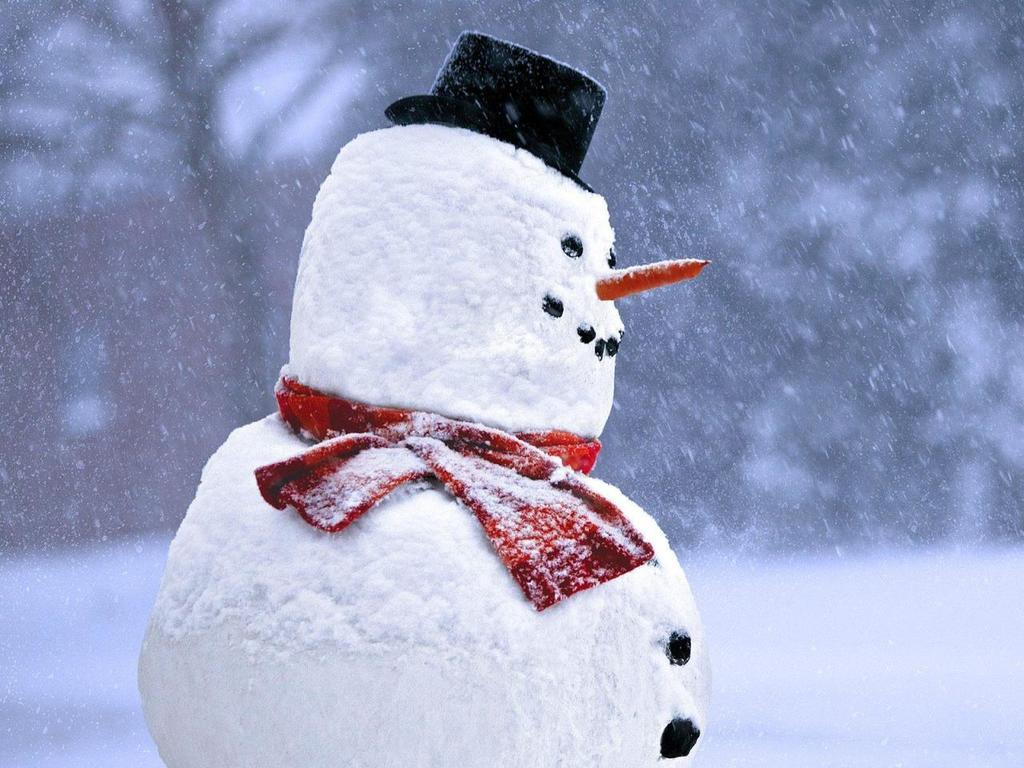What is the main subject of the image? There is a snowman in the image. What can be seen in the background of the image? There is snow and trees in the background of the image. What type of crook is the snowman holding in the image? There is no crook present in the image; the snowman is not holding any object. Can you describe the bear that is interacting with the snowman in the image? There is no bear present in the image; the snowman is the only subject. 